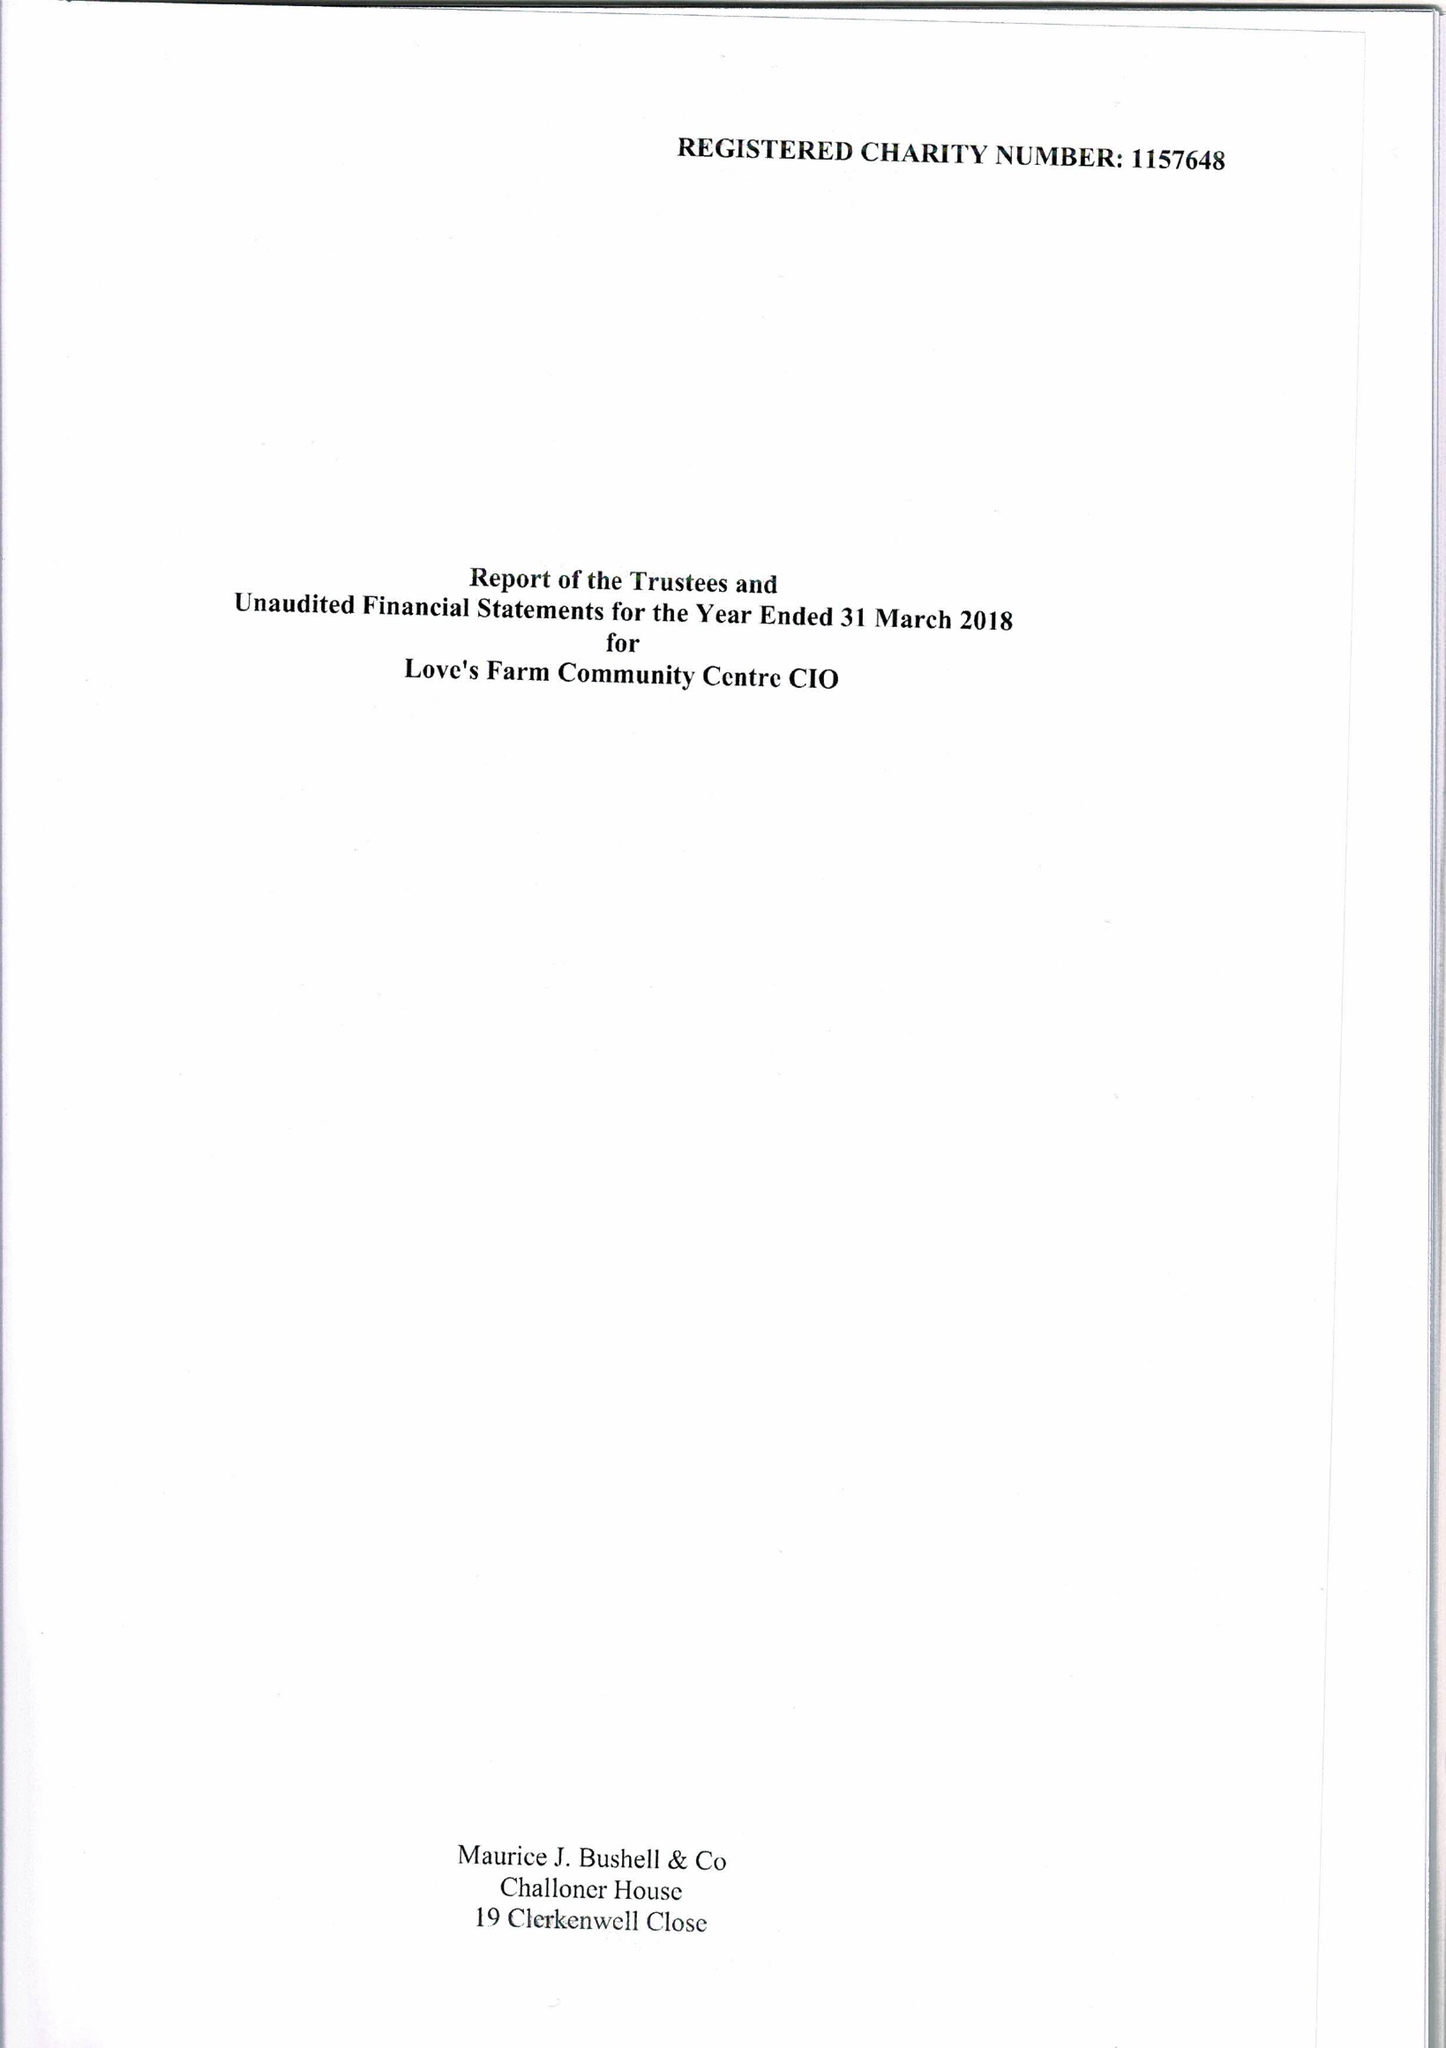What is the value for the spending_annually_in_british_pounds?
Answer the question using a single word or phrase. 101042.00 